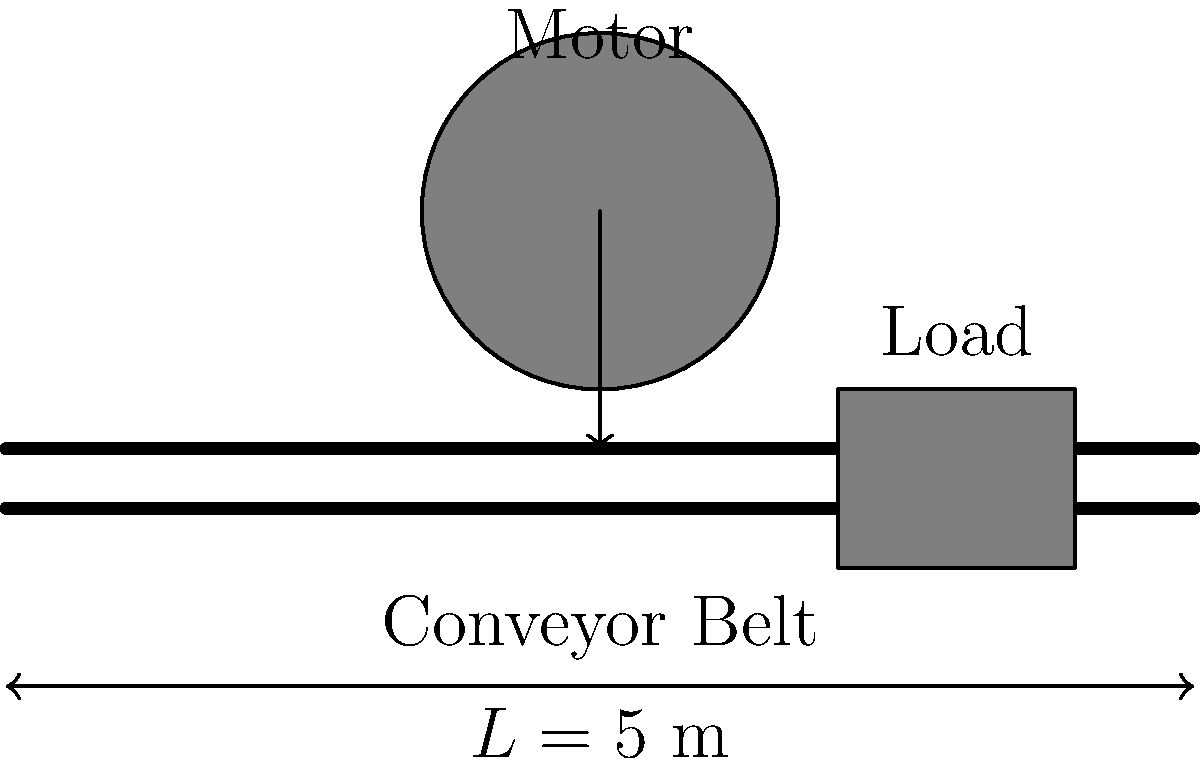As a maintenance engineer at a manufacturing plant in Atlanta, you're tasked with upgrading the motor for a conveyor belt system. The conveyor belt is 5 meters long and needs to move at a speed of 0.5 m/s. The total mass of the belt and its load is 200 kg, and the coefficient of friction between the belt and its support is 0.3. The drive pulley has a radius of 0.1 m. Calculate the minimum torque required for the motor to operate the conveyor belt system effectively. Let's approach this step-by-step, using principles of mechanics and power transmission:

1) First, we need to calculate the force required to move the belt. This force needs to overcome friction:

   $F = \mu N = \mu m g$

   Where:
   $\mu$ is the coefficient of friction (0.3)
   $m$ is the total mass (200 kg)
   $g$ is the acceleration due to gravity (9.81 m/s²)

   $F = 0.3 \times 200 \times 9.81 = 588.6$ N

2) Now, we need to calculate the torque. Torque is the product of force and the radius of the drive pulley:

   $T = F \times r$

   Where:
   $T$ is the torque
   $F$ is the force we calculated (588.6 N)
   $r$ is the radius of the drive pulley (0.1 m)

   $T = 588.6 \times 0.1 = 58.86$ Nm

3) We should also check if this torque is sufficient for the required speed:

   Power $P = F \times v = T \times \omega$

   Where:
   $v$ is the linear speed (0.5 m/s)
   $\omega$ is the angular speed

   $\omega = v / r = 0.5 / 0.1 = 5$ rad/s

   $P = 588.6 \times 0.5 = 294.3$ W

   Checking: $P = 58.86 \times 5 = 294.3$ W

This confirms our calculation is consistent.

Therefore, the minimum torque required for the motor is 58.86 Nm.
Answer: 58.86 Nm 